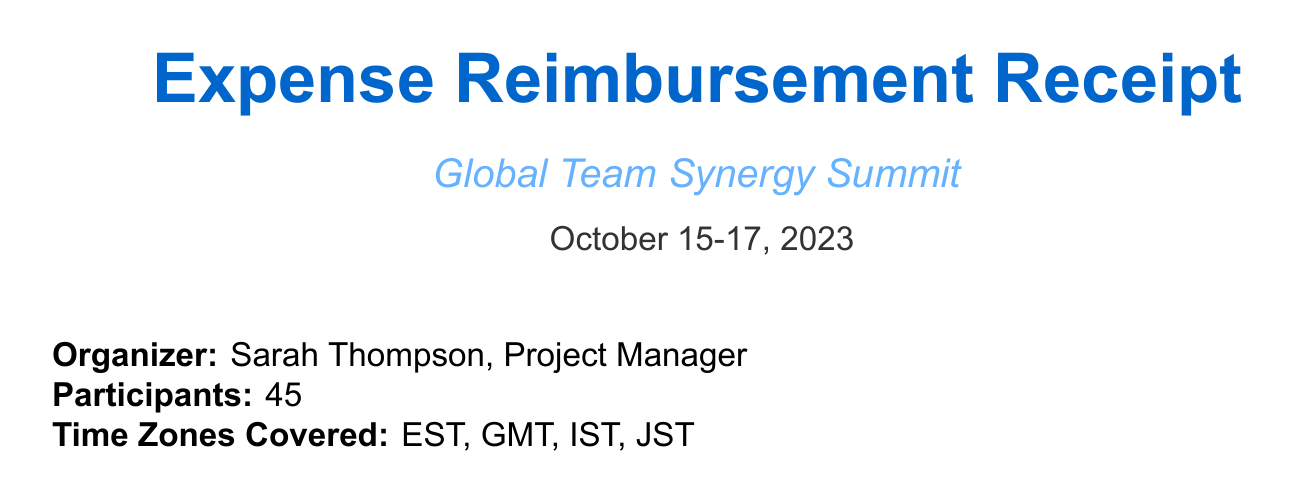What is the event name? The event name is clearly stated at the top of the document.
Answer: Global Team Synergy Summit Who organized the event? The organizer's name and position are mentioned in the document.
Answer: Sarah Thompson, Project Manager How many participants were there? The total number of participants is specified in the document.
Answer: 45 What is the total amount for the expenses? The total amount is listed toward the end of the document.
Answer: $9,759.00 USD What was the cost of the Yoga session? The cost of the virtual wellness activity is indicated in the expenses section.
Answer: $350.00 Which local catering was provided for IST participants? The specific catering item for IST participants is mentioned in the local catering section.
Answer: Lunch platters from Taj Mahal Palace What virtual team-building item was included? The document lists a specific virtual team-building activity.
Answer: Murder Mystery Zoom Experience by The Murder Mystery Co Who approved the expenses? The name of the person who approved the expenses is stated near the end of the document.
Answer: Jennifer Lee What payment method was used? The payment method for the expenses is provided in the document.
Answer: Corporate American Express card 